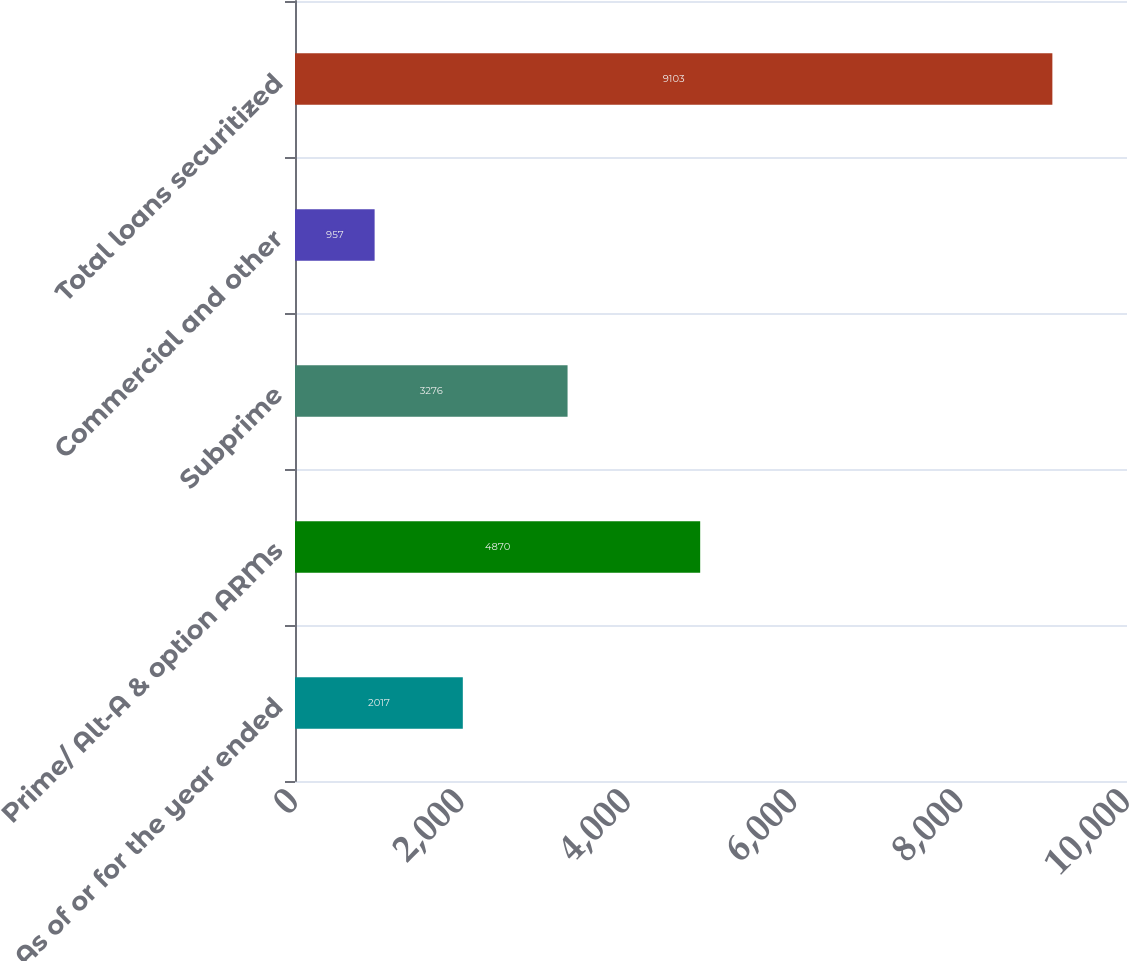Convert chart to OTSL. <chart><loc_0><loc_0><loc_500><loc_500><bar_chart><fcel>As of or for the year ended<fcel>Prime/ Alt-A & option ARMs<fcel>Subprime<fcel>Commercial and other<fcel>Total loans securitized<nl><fcel>2017<fcel>4870<fcel>3276<fcel>957<fcel>9103<nl></chart> 